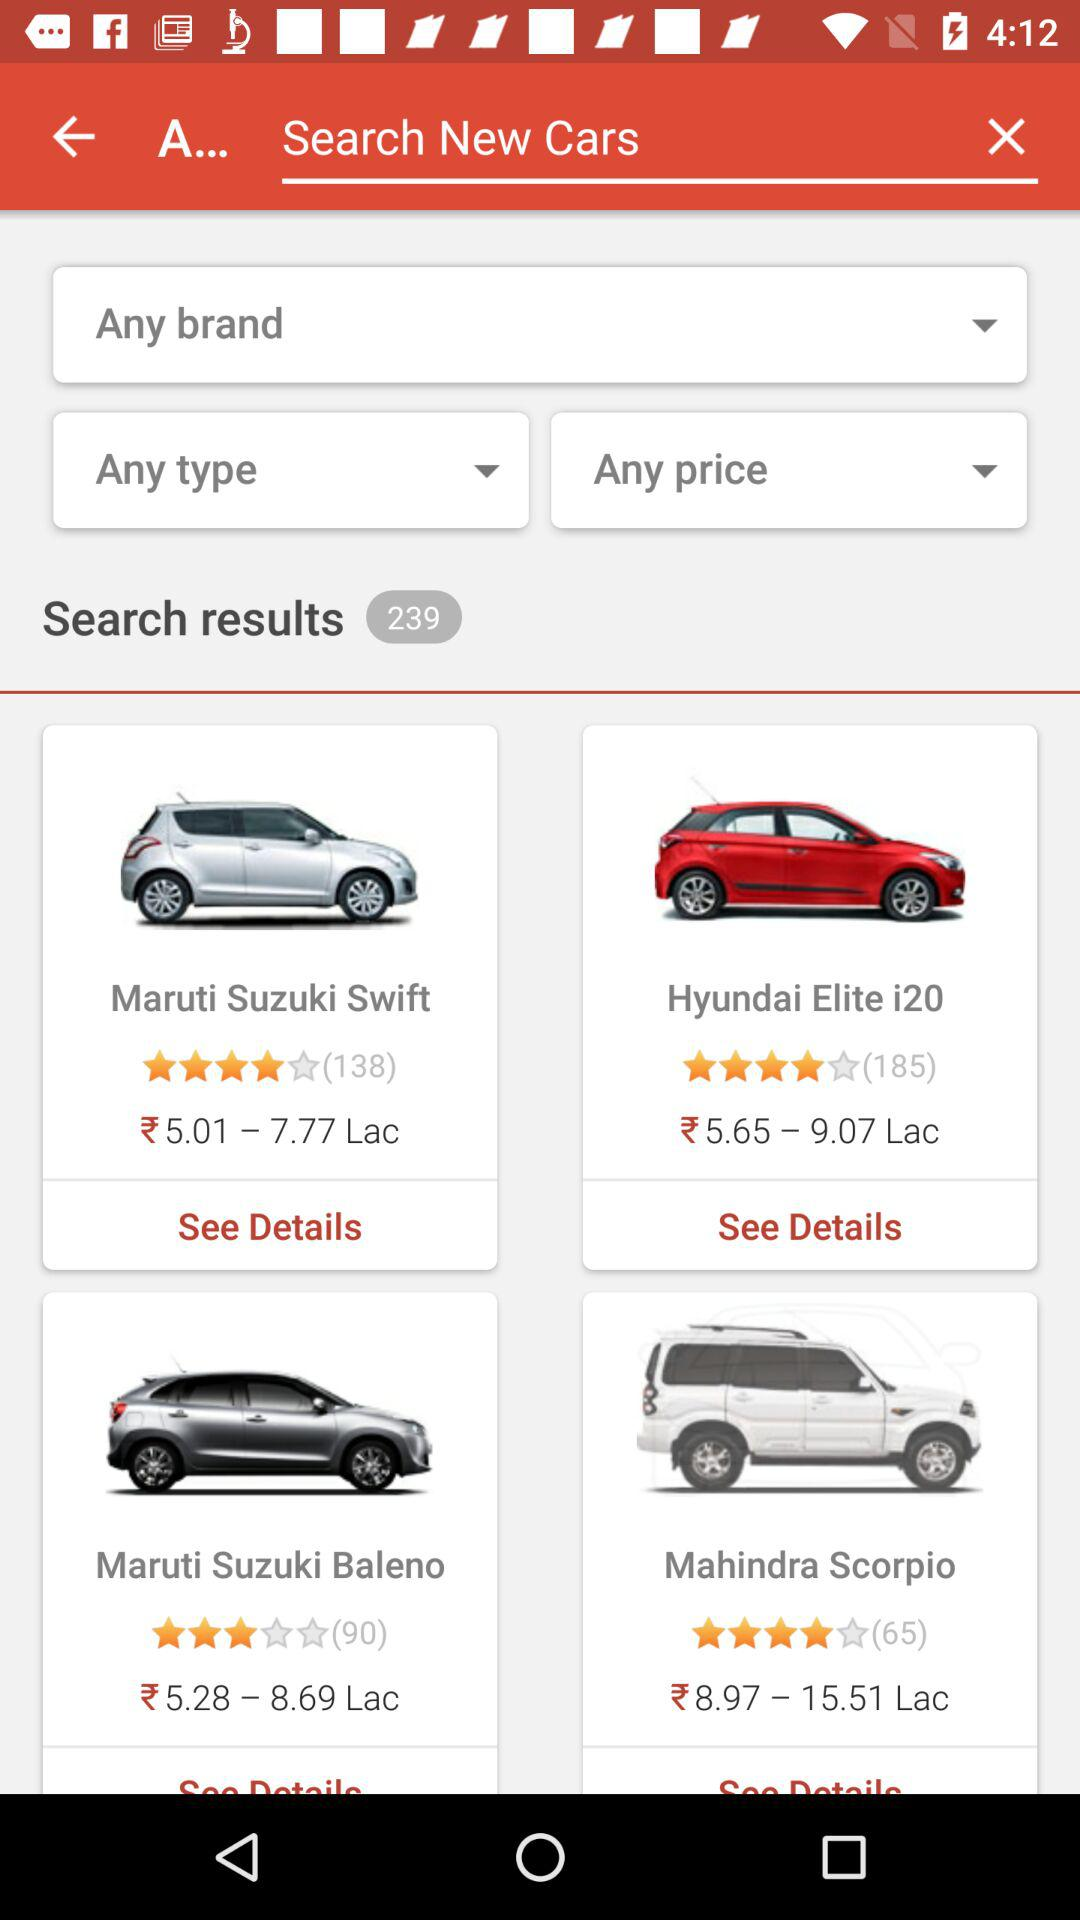How many search results are there? There are 239 search results. 